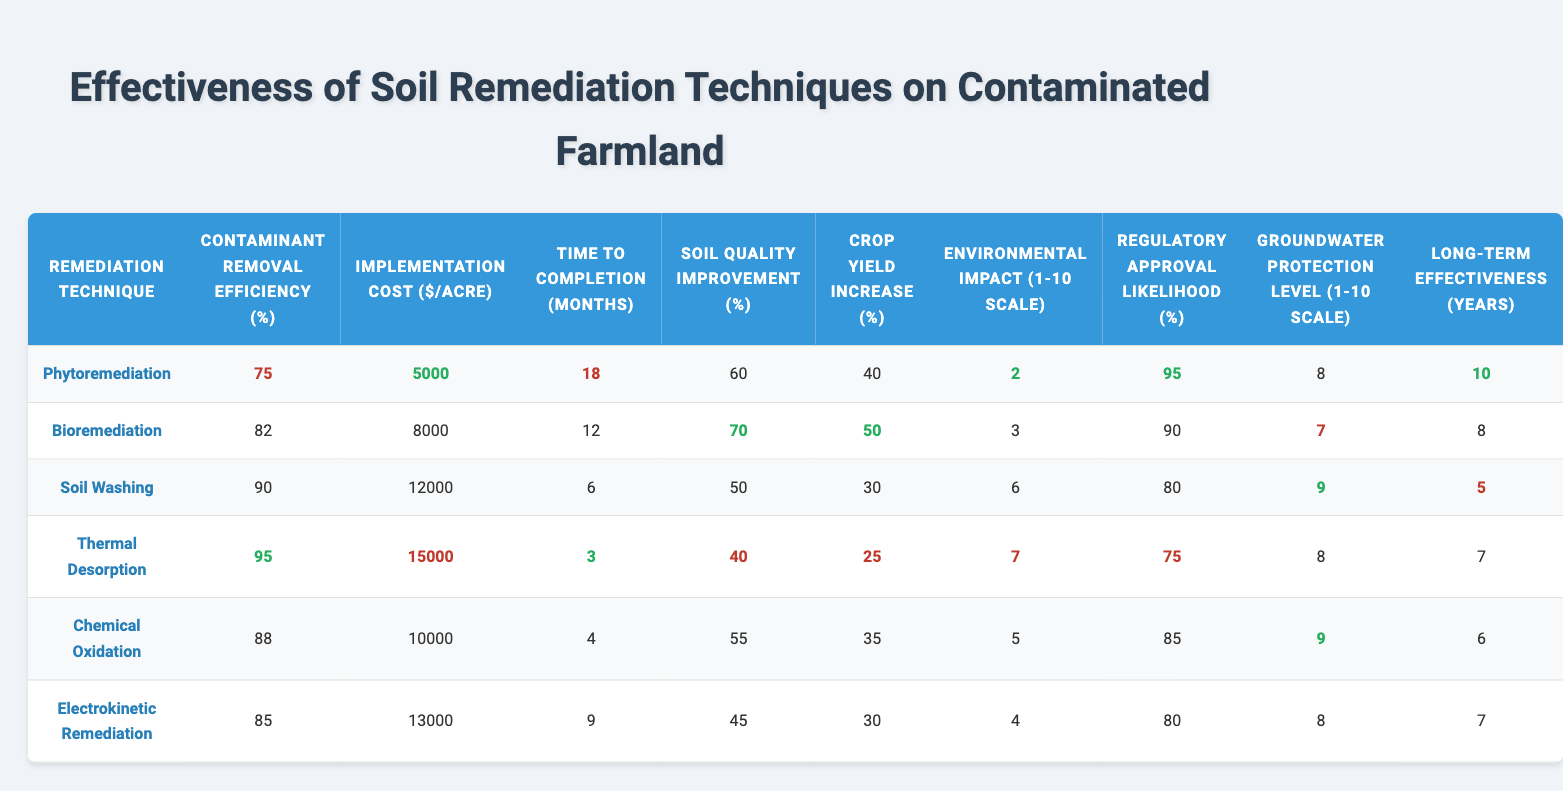What is the contaminant removal efficiency of Soil Washing? The table indicates that the contaminant removal efficiency of Soil Washing is 90%.
Answer: 90% Which remediation technique has the highest implementation cost per acre? By looking at the implementation costs, Thermal Desorption has the highest cost at $15,000 per acre.
Answer: $15,000 How long does it take to complete Chemical Oxidation? The time to completion for Chemical Oxidation, according to the table, is 4 months.
Answer: 4 months What is the average crop yield increase across all remediation techniques? The crop yield increases are 40%, 50%, 30%, 25%, 35%, and 30%. Summing these gives 210%. Dividing by 6 (the number of techniques) results in an average of 35%.
Answer: 35% Which remediation technique has the lowest soil quality improvement percentage? The Soil Washing technique has the lowest soil quality improvement at 50%.
Answer: 50% Is the groundwater protection level for Bioremediation greater than or equal to 7? The groundwater protection level for Bioremediation is 7, which satisfies the condition of being greater than or equal to 7.
Answer: Yes What is the difference in contaminant removal efficiency between Thermal Desorption and Phytoremediation? Thermal Desorption has a contaminant removal efficiency of 95% and Phytoremediation has 75%. The difference is 95% - 75% = 20%.
Answer: 20% Which remediation technique has the lowest environmental impact score? Upon reviewing the scores, Phytoremediation has the lowest environmental impact at 2 on a 1-10 scale.
Answer: 2 What is the long-term effectiveness of Electrokinetic Remediation in years? The long-term effectiveness of Electrokinetic Remediation is 7 years, as shown in the table.
Answer: 7 years If we compare the contaminant removal efficiency of Chemical Oxidation with Bioremediation, which is more effective? Chemical Oxidation has a efficiency of 88%, while Bioremediation has 82%. Since 88% is greater than 82%, Chemical Oxidation is more effective.
Answer: Chemical Oxidation Which technique has the highest regulatory approval likelihood and what is its percentage? According to the data, Phytoremediation has the highest regulatory approval likelihood at 95%.
Answer: 95% 